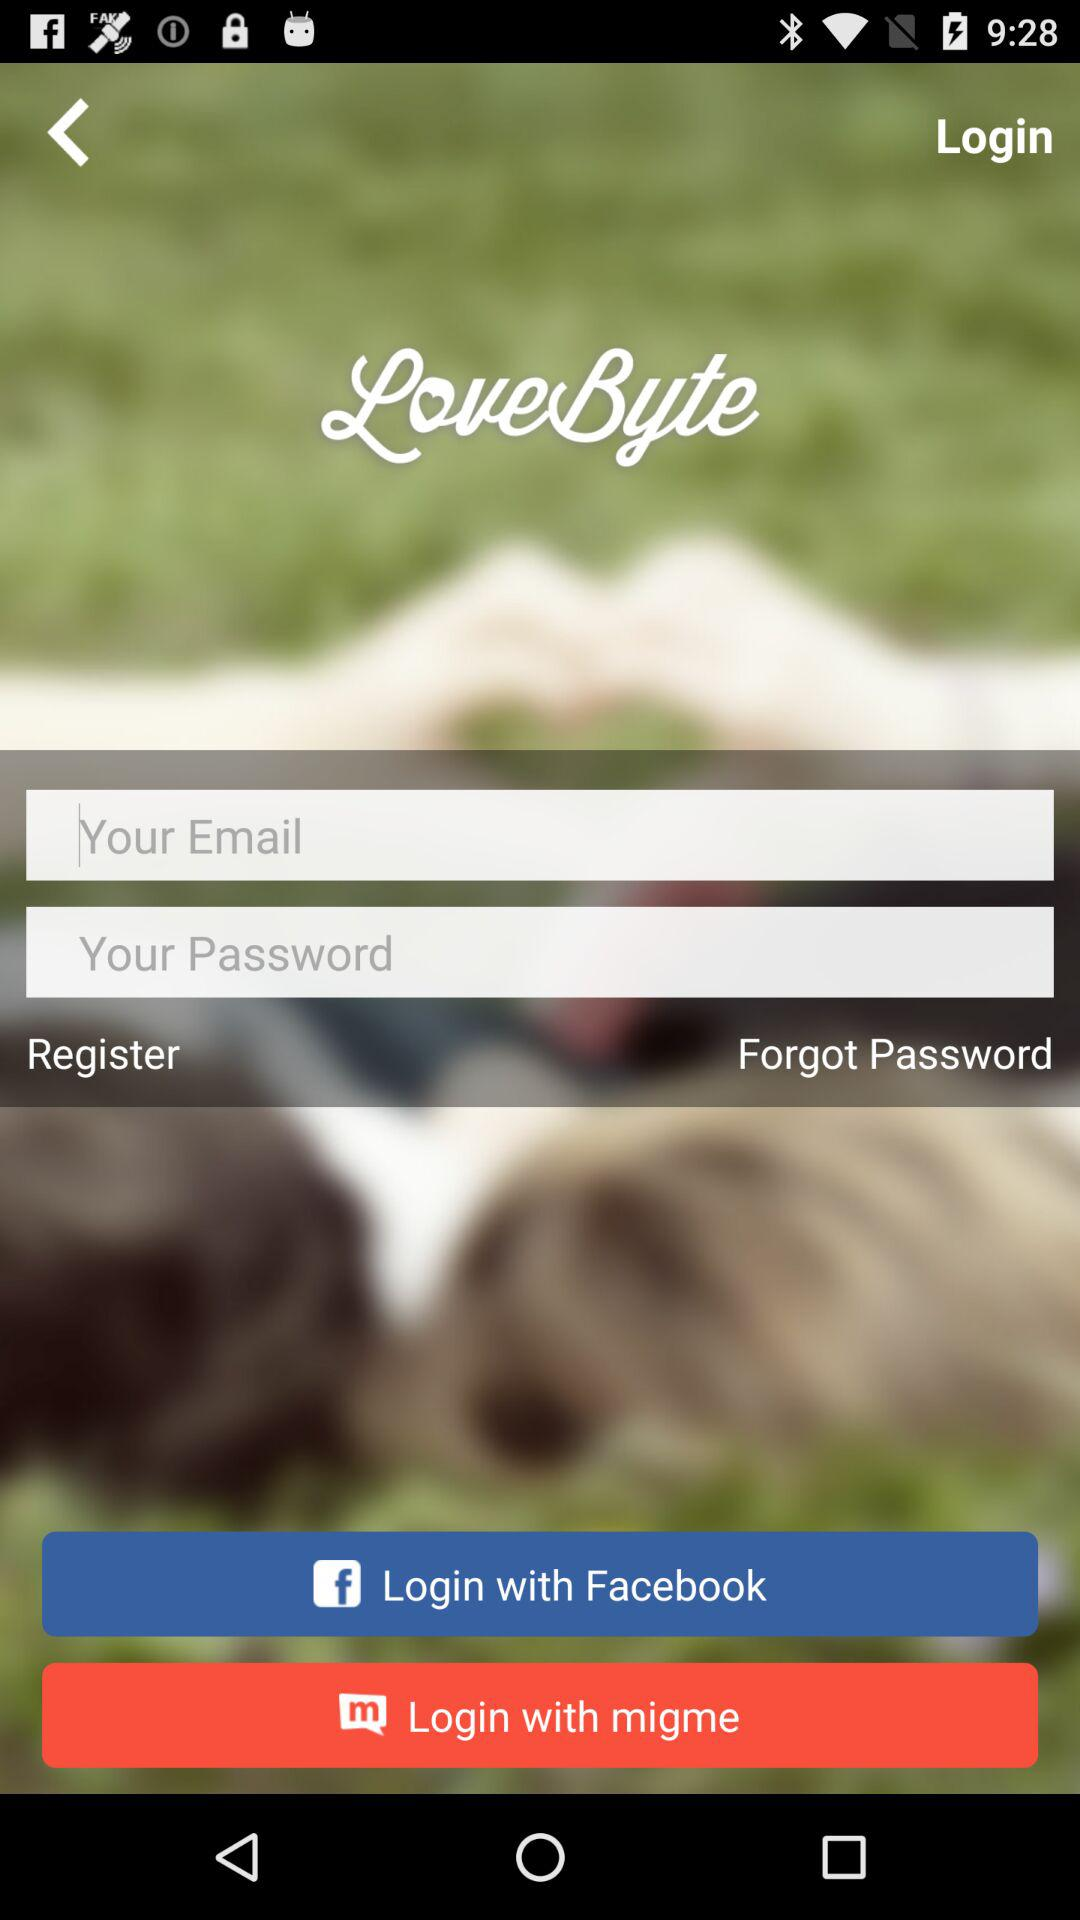What is the name of the application? The name of the application is "LoveByte". 